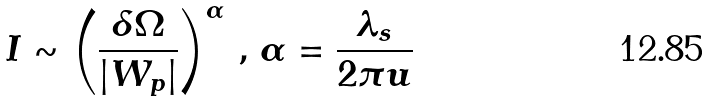<formula> <loc_0><loc_0><loc_500><loc_500>I \sim \left ( \frac { \delta \Omega } { | W _ { p } | } \right ) ^ { \alpha } \, , \, \alpha = \frac { \lambda _ { s } } { 2 \pi u }</formula> 